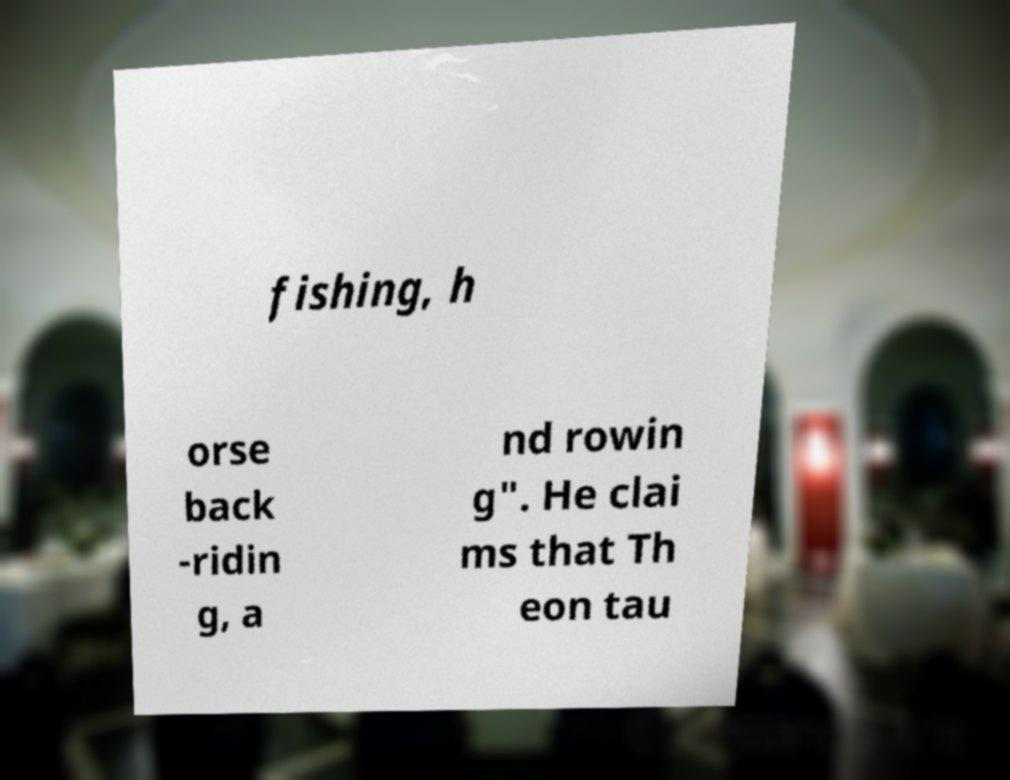Could you assist in decoding the text presented in this image and type it out clearly? fishing, h orse back -ridin g, a nd rowin g". He clai ms that Th eon tau 